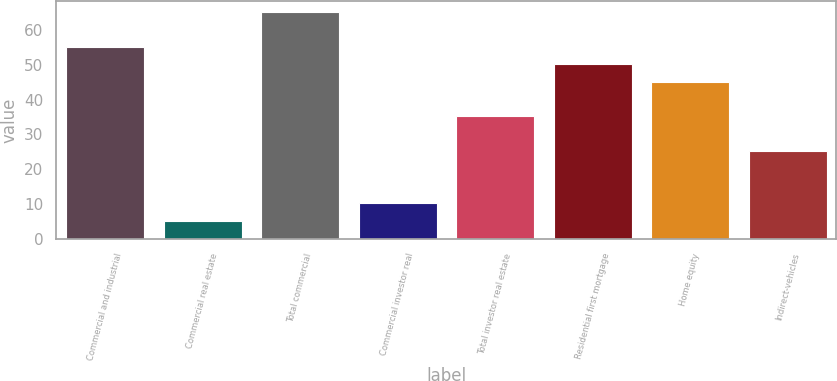<chart> <loc_0><loc_0><loc_500><loc_500><bar_chart><fcel>Commercial and industrial<fcel>Commercial real estate<fcel>Total commercial<fcel>Commercial investor real<fcel>Total investor real estate<fcel>Residential first mortgage<fcel>Home equity<fcel>Indirect-vehicles<nl><fcel>55.08<fcel>5.28<fcel>65.04<fcel>10.26<fcel>35.16<fcel>50.1<fcel>45.12<fcel>25.2<nl></chart> 